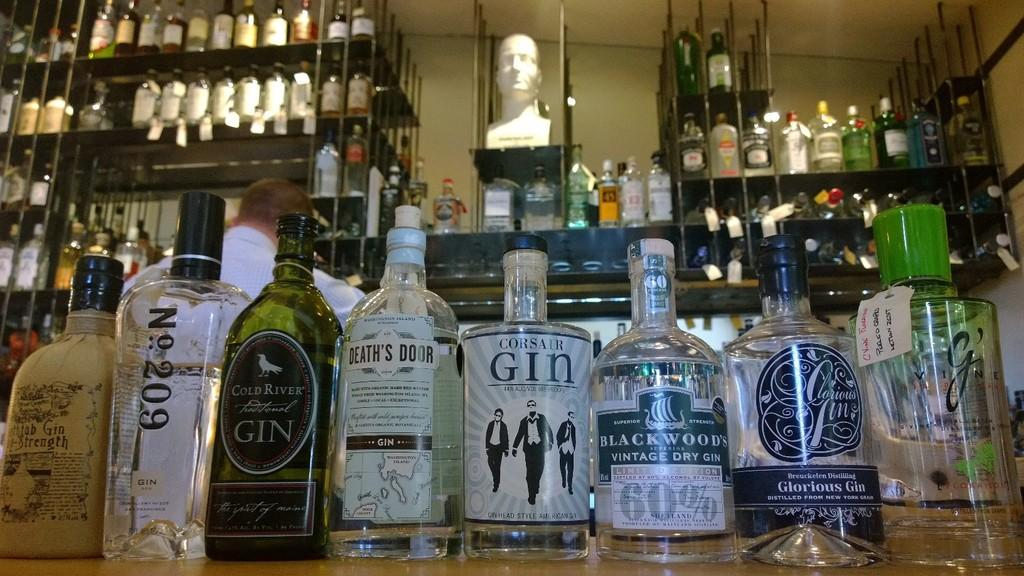<image>
Relay a brief, clear account of the picture shown. Bottle of Corsair Gin with three men in suits on the label inside of a bar. 